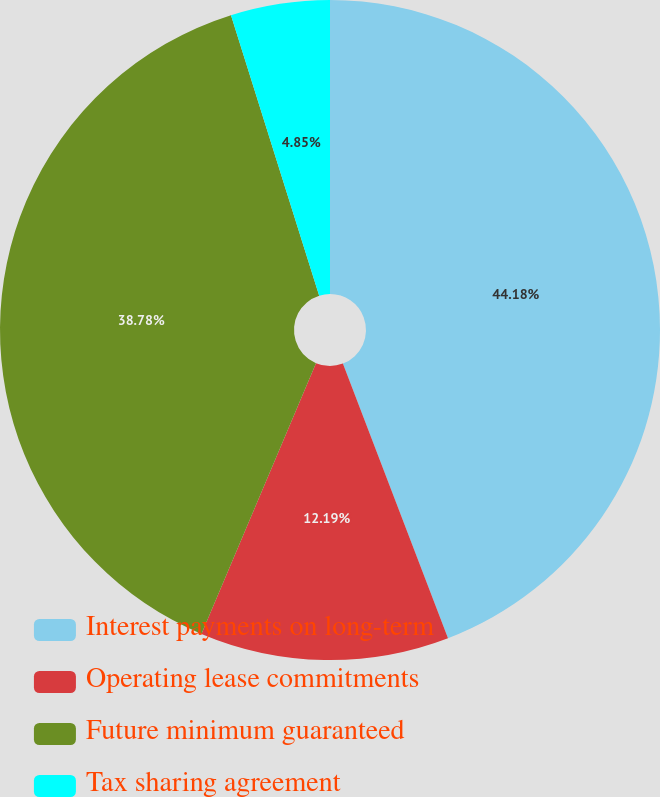<chart> <loc_0><loc_0><loc_500><loc_500><pie_chart><fcel>Interest payments on long-term<fcel>Operating lease commitments<fcel>Future minimum guaranteed<fcel>Tax sharing agreement<nl><fcel>44.18%<fcel>12.19%<fcel>38.78%<fcel>4.85%<nl></chart> 